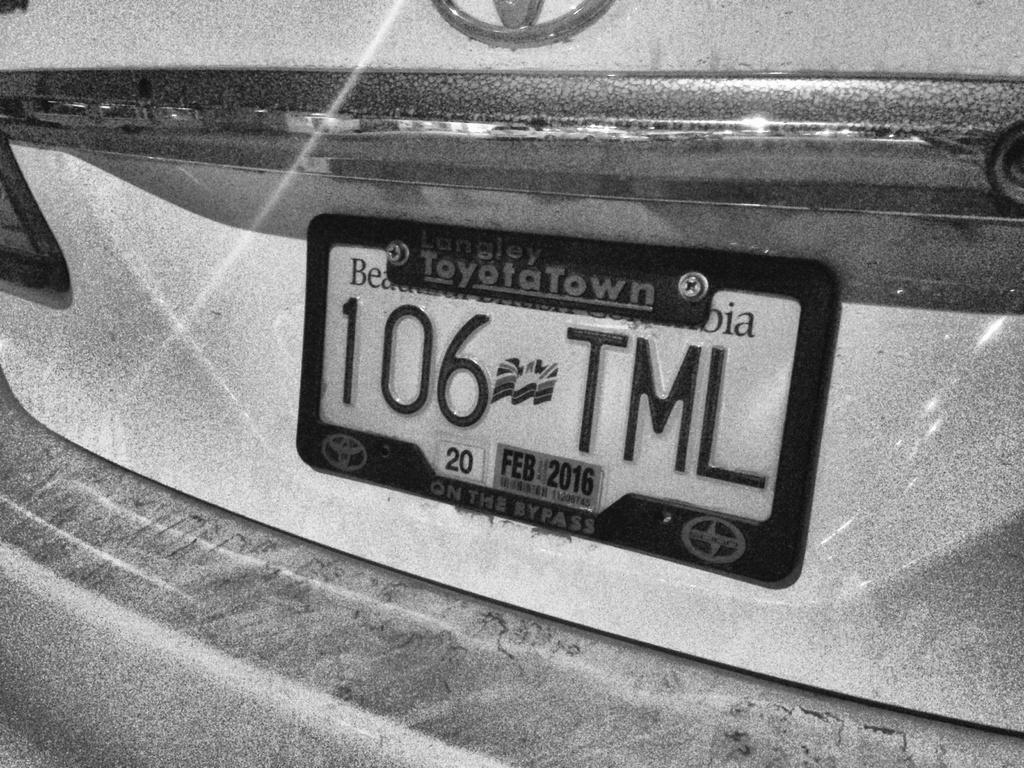Describe this image in one or two sentences. This is a black and white image. In this image we can see name plate of the motor vehicle. 